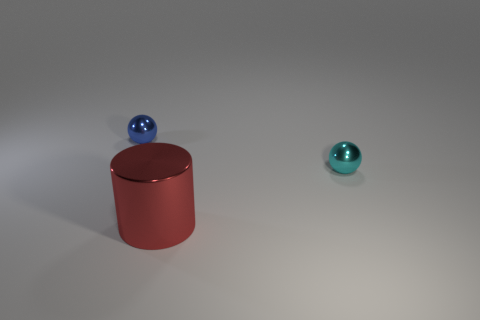Add 1 tiny blue metallic things. How many objects exist? 4 Subtract all balls. How many objects are left? 1 Add 2 blue shiny things. How many blue shiny things exist? 3 Subtract 0 cyan blocks. How many objects are left? 3 Subtract all large red objects. Subtract all cyan shiny balls. How many objects are left? 1 Add 2 big red shiny things. How many big red shiny things are left? 3 